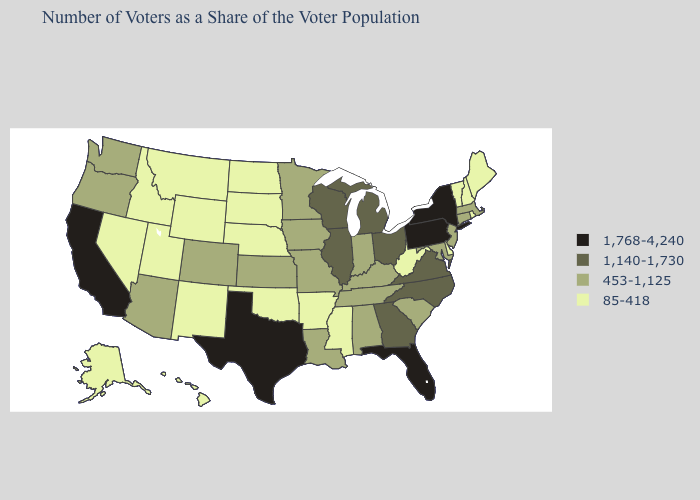What is the lowest value in states that border Connecticut?
Give a very brief answer. 85-418. What is the lowest value in the West?
Be succinct. 85-418. What is the lowest value in the USA?
Write a very short answer. 85-418. Does New York have the highest value in the Northeast?
Quick response, please. Yes. What is the highest value in the USA?
Answer briefly. 1,768-4,240. Which states have the highest value in the USA?
Be succinct. California, Florida, New York, Pennsylvania, Texas. Which states have the highest value in the USA?
Concise answer only. California, Florida, New York, Pennsylvania, Texas. What is the highest value in the USA?
Write a very short answer. 1,768-4,240. What is the value of Iowa?
Keep it brief. 453-1,125. What is the value of New Mexico?
Quick response, please. 85-418. Does the first symbol in the legend represent the smallest category?
Short answer required. No. What is the lowest value in the USA?
Quick response, please. 85-418. How many symbols are there in the legend?
Concise answer only. 4. Name the states that have a value in the range 1,140-1,730?
Quick response, please. Georgia, Illinois, Michigan, North Carolina, Ohio, Virginia, Wisconsin. Does Hawaii have a lower value than Maine?
Be succinct. No. 